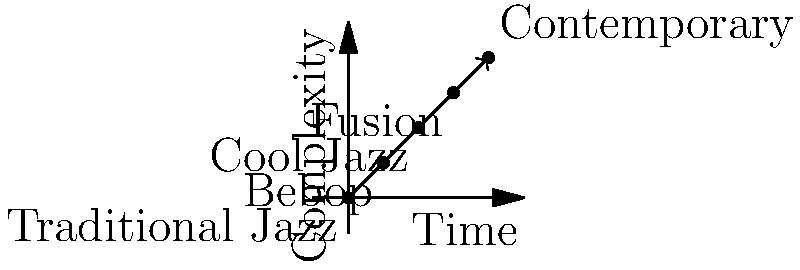In the vector diagram illustrating the evolution of musical instruments from traditional jazz to contemporary genres, which genre represents the midpoint between traditional jazz and contemporary music? To determine the midpoint genre between traditional jazz and contemporary music, let's follow these steps:

1. Identify the starting point: Traditional Jazz (0,0)
2. Identify the endpoint: Contemporary (4,4)
3. Note the genres in order of progression:
   a. Traditional Jazz (0,0)
   b. Bebop (1,1)
   c. Cool Jazz (2,2)
   d. Fusion (3,3)
   e. Contemporary (4,4)
4. Calculate the midpoint:
   - The midpoint is halfway between the start and end points
   - In this case, it's at coordinates (2,2)
5. Identify the genre at (2,2): Cool Jazz

Therefore, Cool Jazz represents the midpoint between traditional jazz and contemporary music in this evolution diagram.
Answer: Cool Jazz 